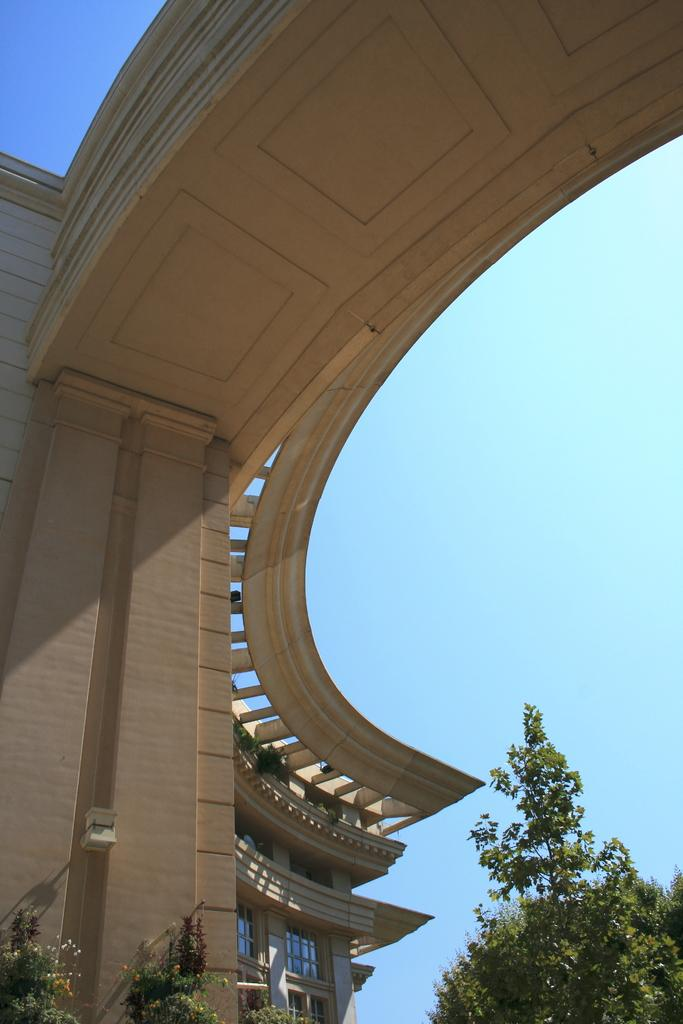What type of view is shown in the image? The image is an outside view. What structure can be seen on the left side of the image? There is a building on the left side of the image. What type of vegetation is at the bottom of the image? There are trees at the bottom of the image. What is visible at the top of the image? The sky is visible at the top of the image. What arithmetic problem is being solved by the team in the image? There is no team or arithmetic problem present in the image. What additional detail can be seen on the building in the image? The provided facts do not mention any specific details about the building, so we cannot answer this question. 